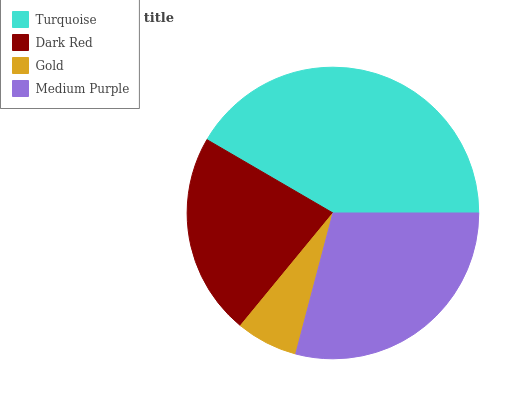Is Gold the minimum?
Answer yes or no. Yes. Is Turquoise the maximum?
Answer yes or no. Yes. Is Dark Red the minimum?
Answer yes or no. No. Is Dark Red the maximum?
Answer yes or no. No. Is Turquoise greater than Dark Red?
Answer yes or no. Yes. Is Dark Red less than Turquoise?
Answer yes or no. Yes. Is Dark Red greater than Turquoise?
Answer yes or no. No. Is Turquoise less than Dark Red?
Answer yes or no. No. Is Medium Purple the high median?
Answer yes or no. Yes. Is Dark Red the low median?
Answer yes or no. Yes. Is Gold the high median?
Answer yes or no. No. Is Medium Purple the low median?
Answer yes or no. No. 